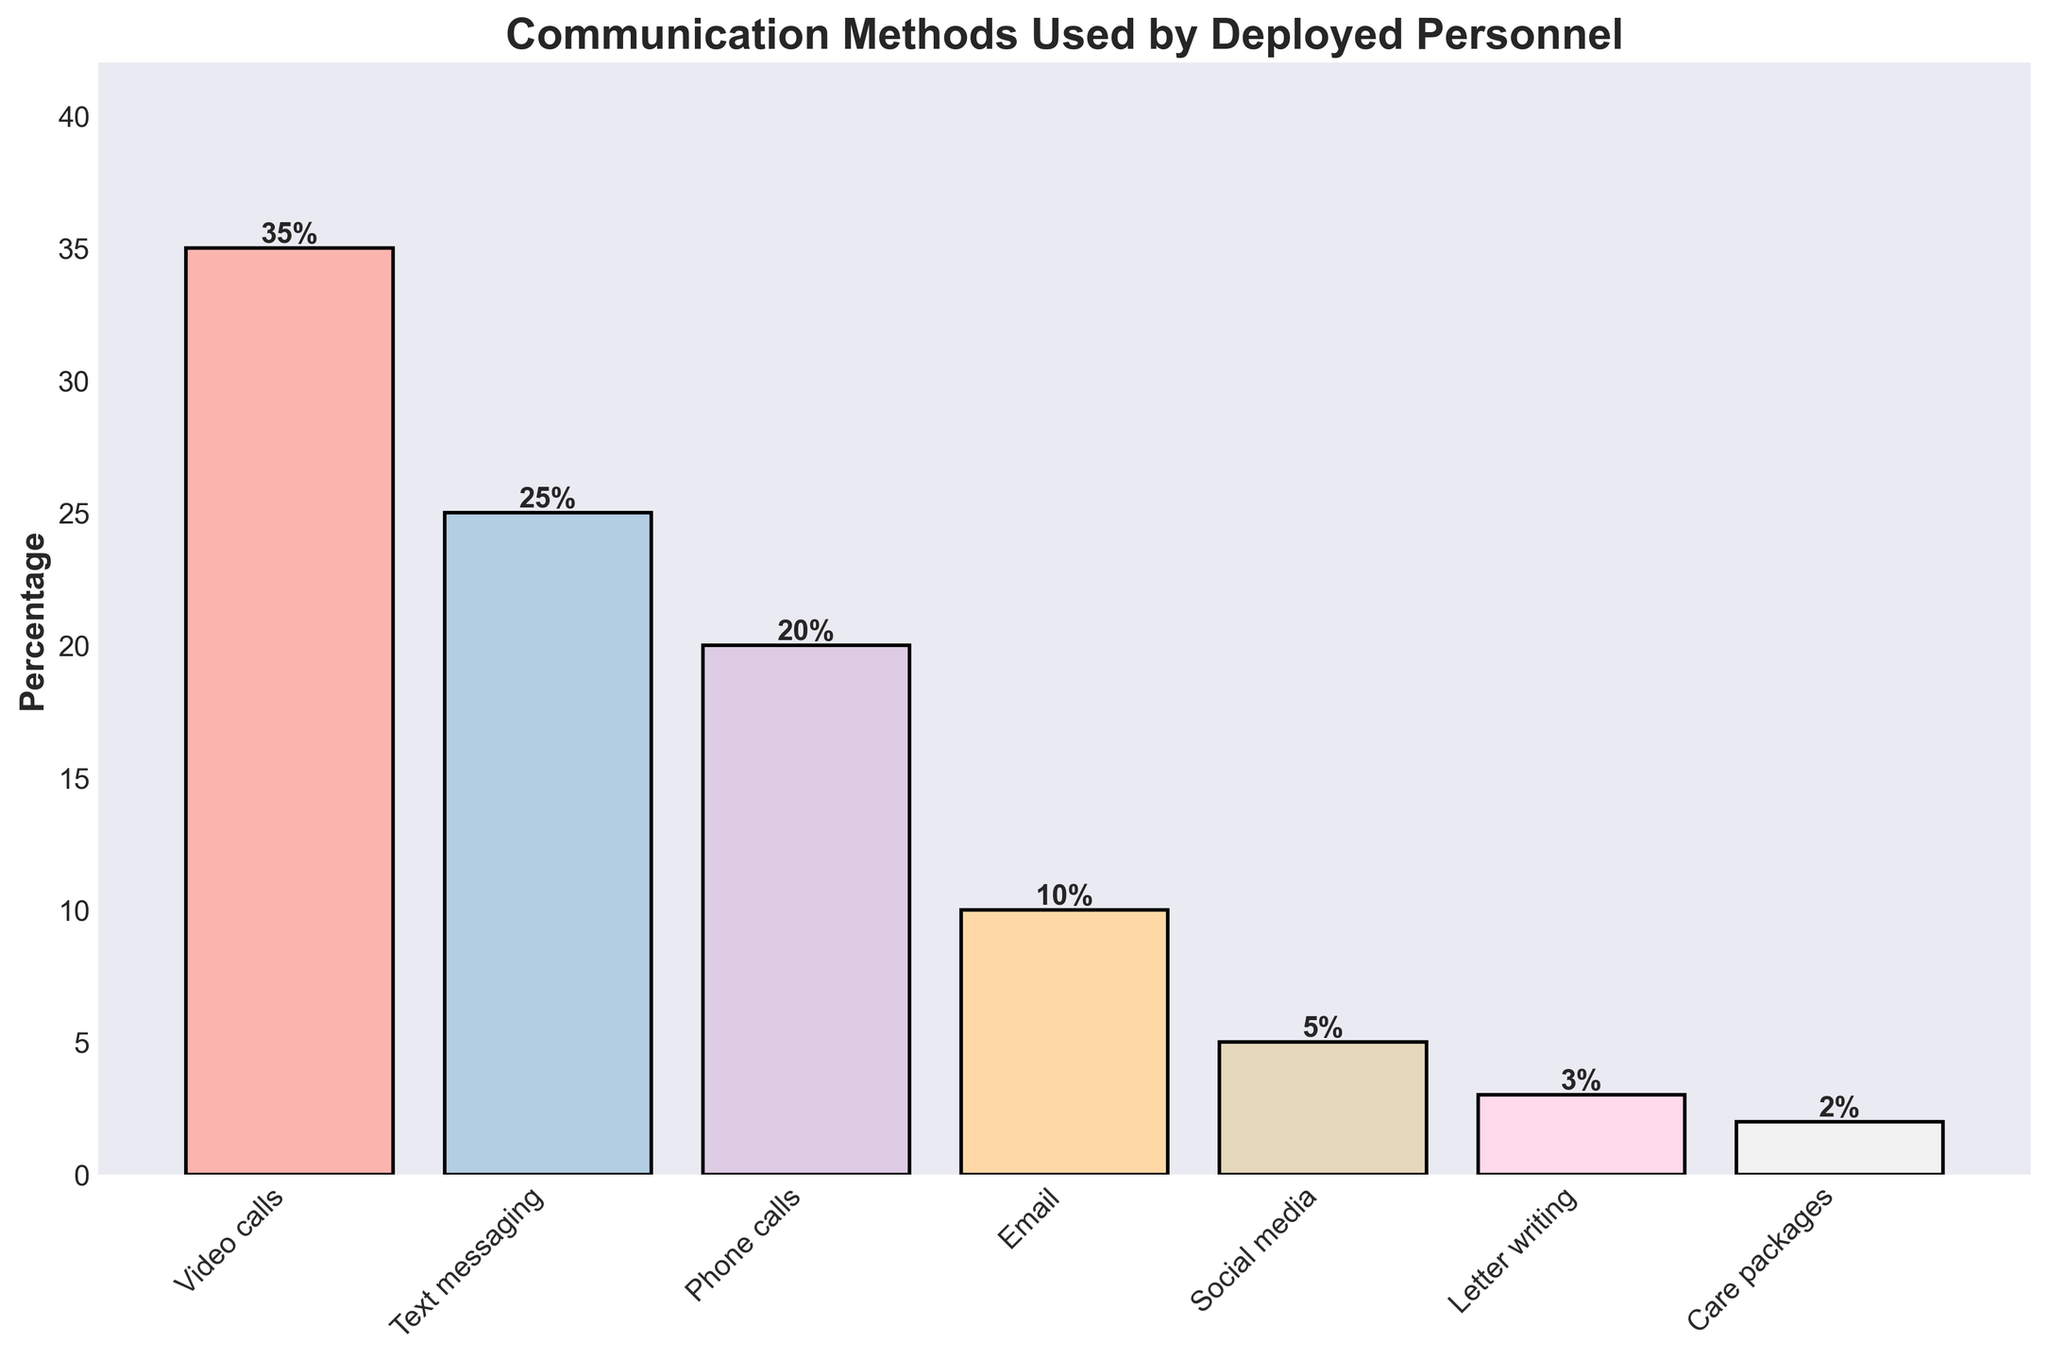Which communication method is used the most by deployed personnel? The highest bar in the chart represents the communication method that is used the most by deployed personnel. Based on the data, this is video calls at 35%.
Answer: Video calls What is the percentage difference between the most used and the least used communication methods? The most used communication method is video calls at 35% and the least used is care packages at 2%. The percentage difference is calculated as 35% - 2% = 33%.
Answer: 33% Which two communication methods combined make up 45% of the total usage? Looking through the chart, the two methods that sum up to 45% are video calls and email. Video calls account for 35% and email for 10%, adding up to 35% + 10% = 45%.
Answer: Video calls and email How does the usage of phone calls compare to the usage of text messaging? The bar for phone calls shows a 20% usage rate, while the bar for text messaging shows a 25% usage rate. Thus, text messaging is used more by 5% compared to phone calls.
Answer: Text messaging is used 5% more than phone calls What is the total percentage for visual communications (video calls and phone calls)? Visual communications include video calls and phone calls. Video calls are 35% and phone calls are 20%. Summing these gives 35% + 20% = 55%.
Answer: 55% Which communication method has a height closest to 10%? By examining the heights of the bars, the communication method closest to 10% is email, which has a 10% usage rate.
Answer: Email What is the median usage percentage of all the communication methods? Listing the percentages in ascending order: 2%, 3%, 5%, 10%, 20%, 25%, 35%. The median is the middle value, which is 10%.
Answer: 10% If you combine the usage percentages of letter writing and care packages, how does the total compare to social media usage? Letter writing is 3% and care packages are 2%. Together, they make 3% + 2% = 5%, which is equal to the usage percentage of social media.
Answer: Equal to social media What is the percentage gap between the third most used and the least used communication methods? The third most used method is phone calls at 20% and the least used is care packages at 2%. The percentage gap is 20% - 2% = 18%.
Answer: 18% 